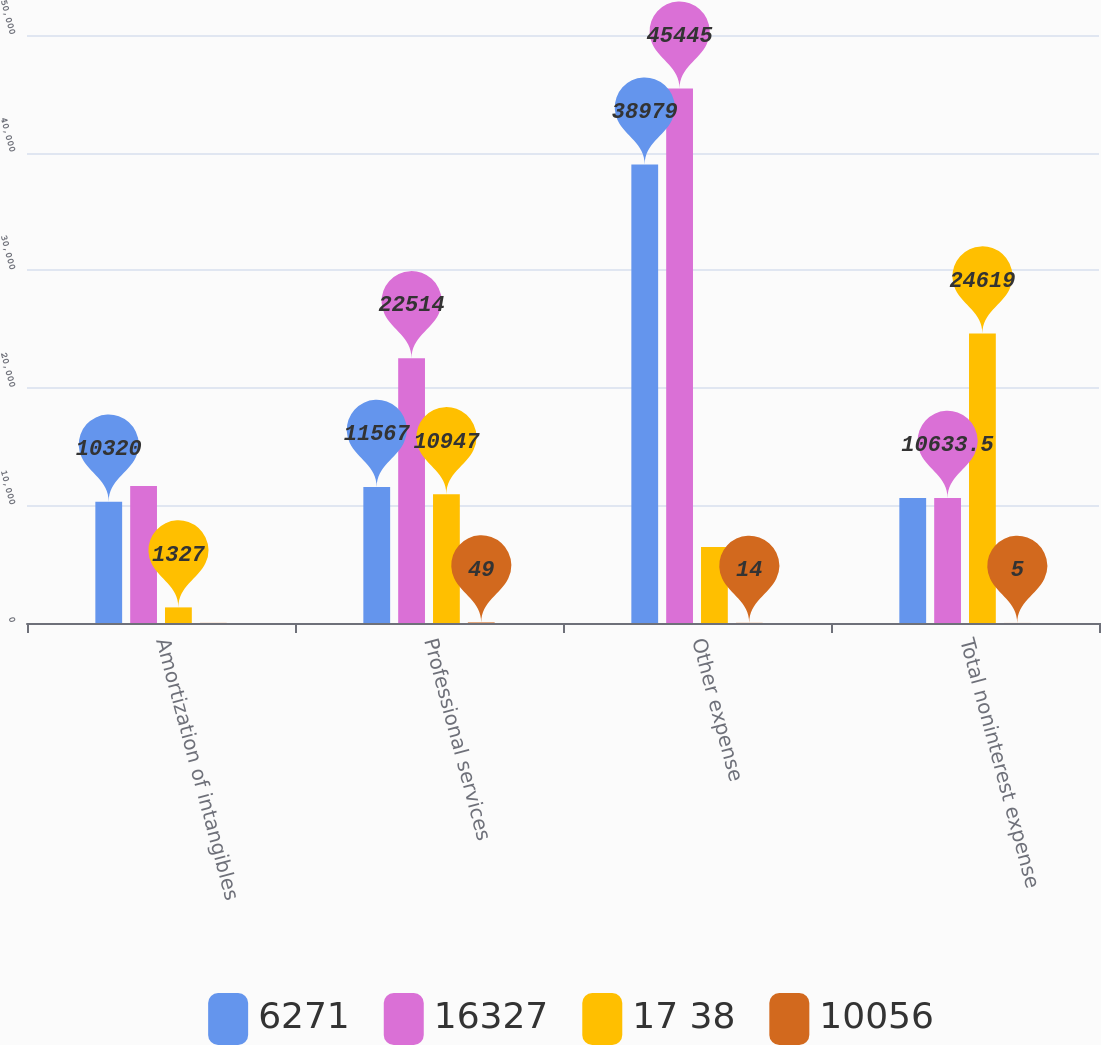Convert chart to OTSL. <chart><loc_0><loc_0><loc_500><loc_500><stacked_bar_chart><ecel><fcel>Amortization of intangibles<fcel>Professional services<fcel>Other expense<fcel>Total noninterest expense<nl><fcel>6271<fcel>10320<fcel>11567<fcel>38979<fcel>10633.5<nl><fcel>16327<fcel>11647<fcel>22514<fcel>45445<fcel>10633.5<nl><fcel>17 38<fcel>1327<fcel>10947<fcel>6466<fcel>24619<nl><fcel>10056<fcel>11<fcel>49<fcel>14<fcel>5<nl></chart> 